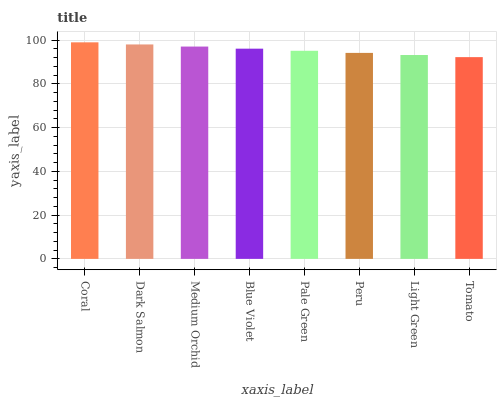Is Tomato the minimum?
Answer yes or no. Yes. Is Coral the maximum?
Answer yes or no. Yes. Is Dark Salmon the minimum?
Answer yes or no. No. Is Dark Salmon the maximum?
Answer yes or no. No. Is Coral greater than Dark Salmon?
Answer yes or no. Yes. Is Dark Salmon less than Coral?
Answer yes or no. Yes. Is Dark Salmon greater than Coral?
Answer yes or no. No. Is Coral less than Dark Salmon?
Answer yes or no. No. Is Blue Violet the high median?
Answer yes or no. Yes. Is Pale Green the low median?
Answer yes or no. Yes. Is Dark Salmon the high median?
Answer yes or no. No. Is Tomato the low median?
Answer yes or no. No. 